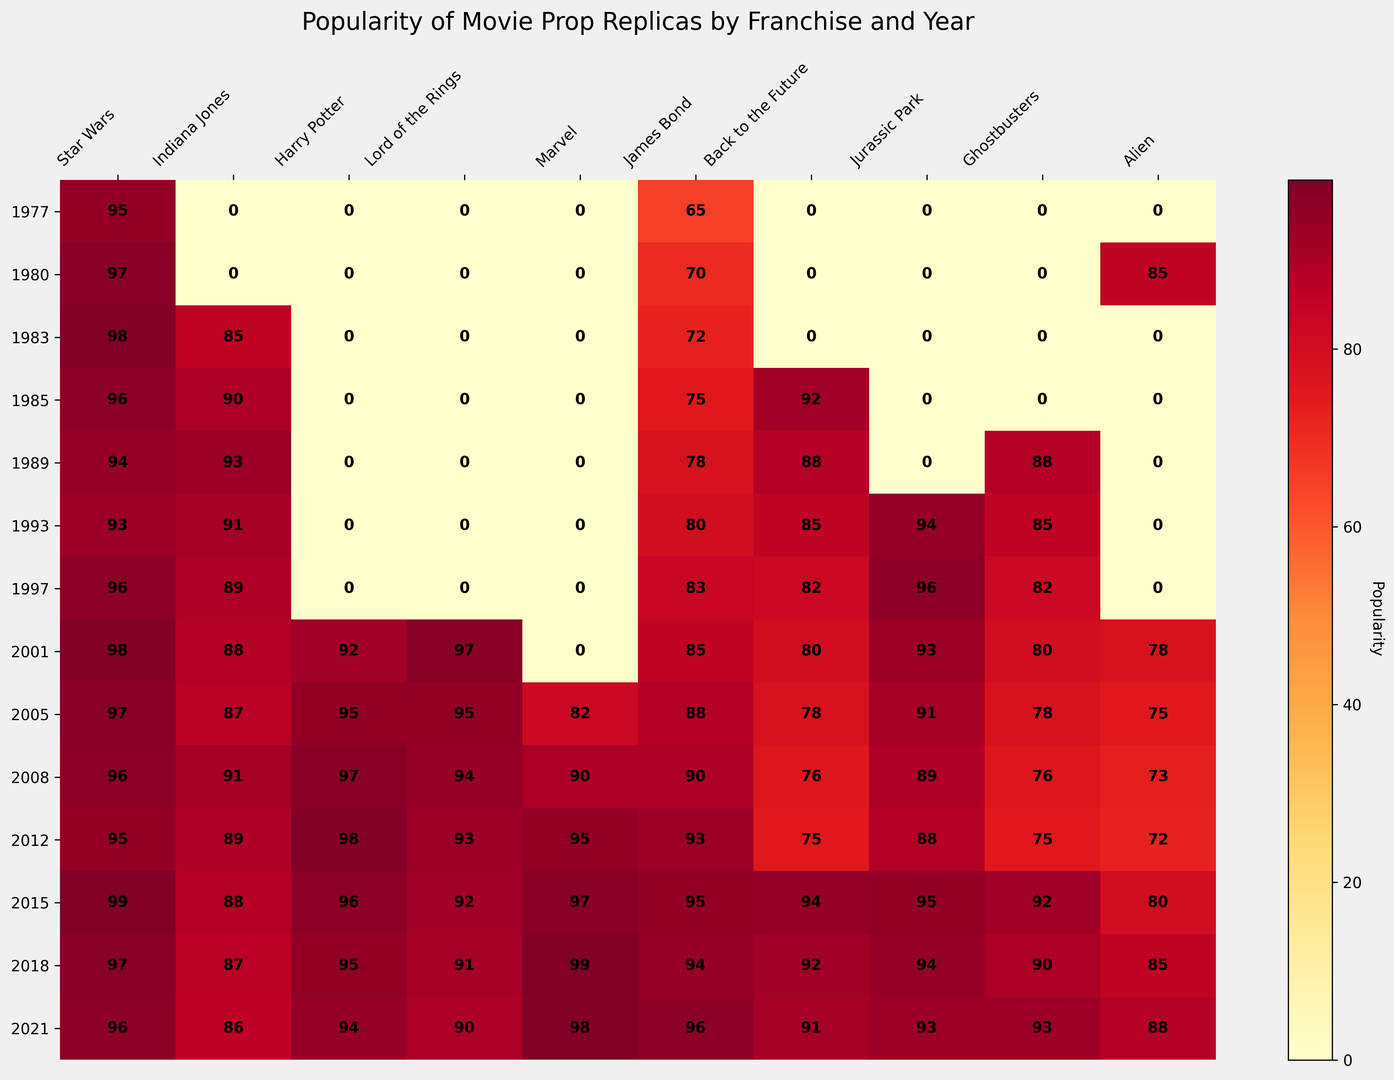What year had the highest popularity for 'Marvel' movie prop replicas? Look for the brightest red color in the 'Marvel' column, which corresponds to the highest number.
Answer: 2018 Which franchise had the most consistent popularity across the years? Compare the color consistency across all years and franchises. A franchise with a uniformly bright color across all years had the most consistent popularity.
Answer: Star Wars What was the popularity of 'Back to the Future' movie prop replicas in 1985 and 2015, and what is the difference? Find the numerical values in the 'Back to the Future' row for 1985 and 2015, then calculate the difference.
Answer: Popularity in 1985: 92, Popularity in 2015: 94, Difference: 2 Which movie had the lowest popularity for 'Jurassic Park' prop replicas, and in what year did it occur? Find the darkest color in the 'Jurassic Park' column to identify the least popular year.
Answer: 1980 Compare the popularity of 'Harry Potter' prop replicas in 2001 and 2008. Which year was more popular? Look at the numerical values or the color intensity for 'Harry Potter' in both 2001 and 2008. The higher value or more intense color indicates more popularity.
Answer: 2008 In which year did 'Star Wars' prop replicas start gaining popularity based on the heatmap? Identify the year where the 'Star Wars' column first shows a bright red or high-value number.
Answer: 1977 How does the popularity of 'Indiana Jones' prop replicas in 1983 compare to 'Ghostbusters' in the same year? Compare the numerical values or color intensity in 1983 for both 'Indiana Jones' and 'Ghostbusters'.
Answer: Indiana Jones: 85, Ghostbusters: 0, Indiana Jones is more popular What’s the average popularity of 'Lord of the Rings' movie prop replicas over the available years? Sum the popularity values for 'Lord of the Rings' and divide by the number of years (2001-2021).
Answer: Total: 97+95+94+93+92+91+90 = 652, Average: 652 / 7 = 93.14 Which year has the highest overall popularity across all franchises? Sum the numerical values for each row (year) and identify the maximum.
Answer: 2015 In which year did 'James Bond' prop replicas reach their peak popularity, and what was the value? Identify the year with the highest numerical value or the brightest color in the 'James Bond' column.
Answer: 2021, Value: 96 